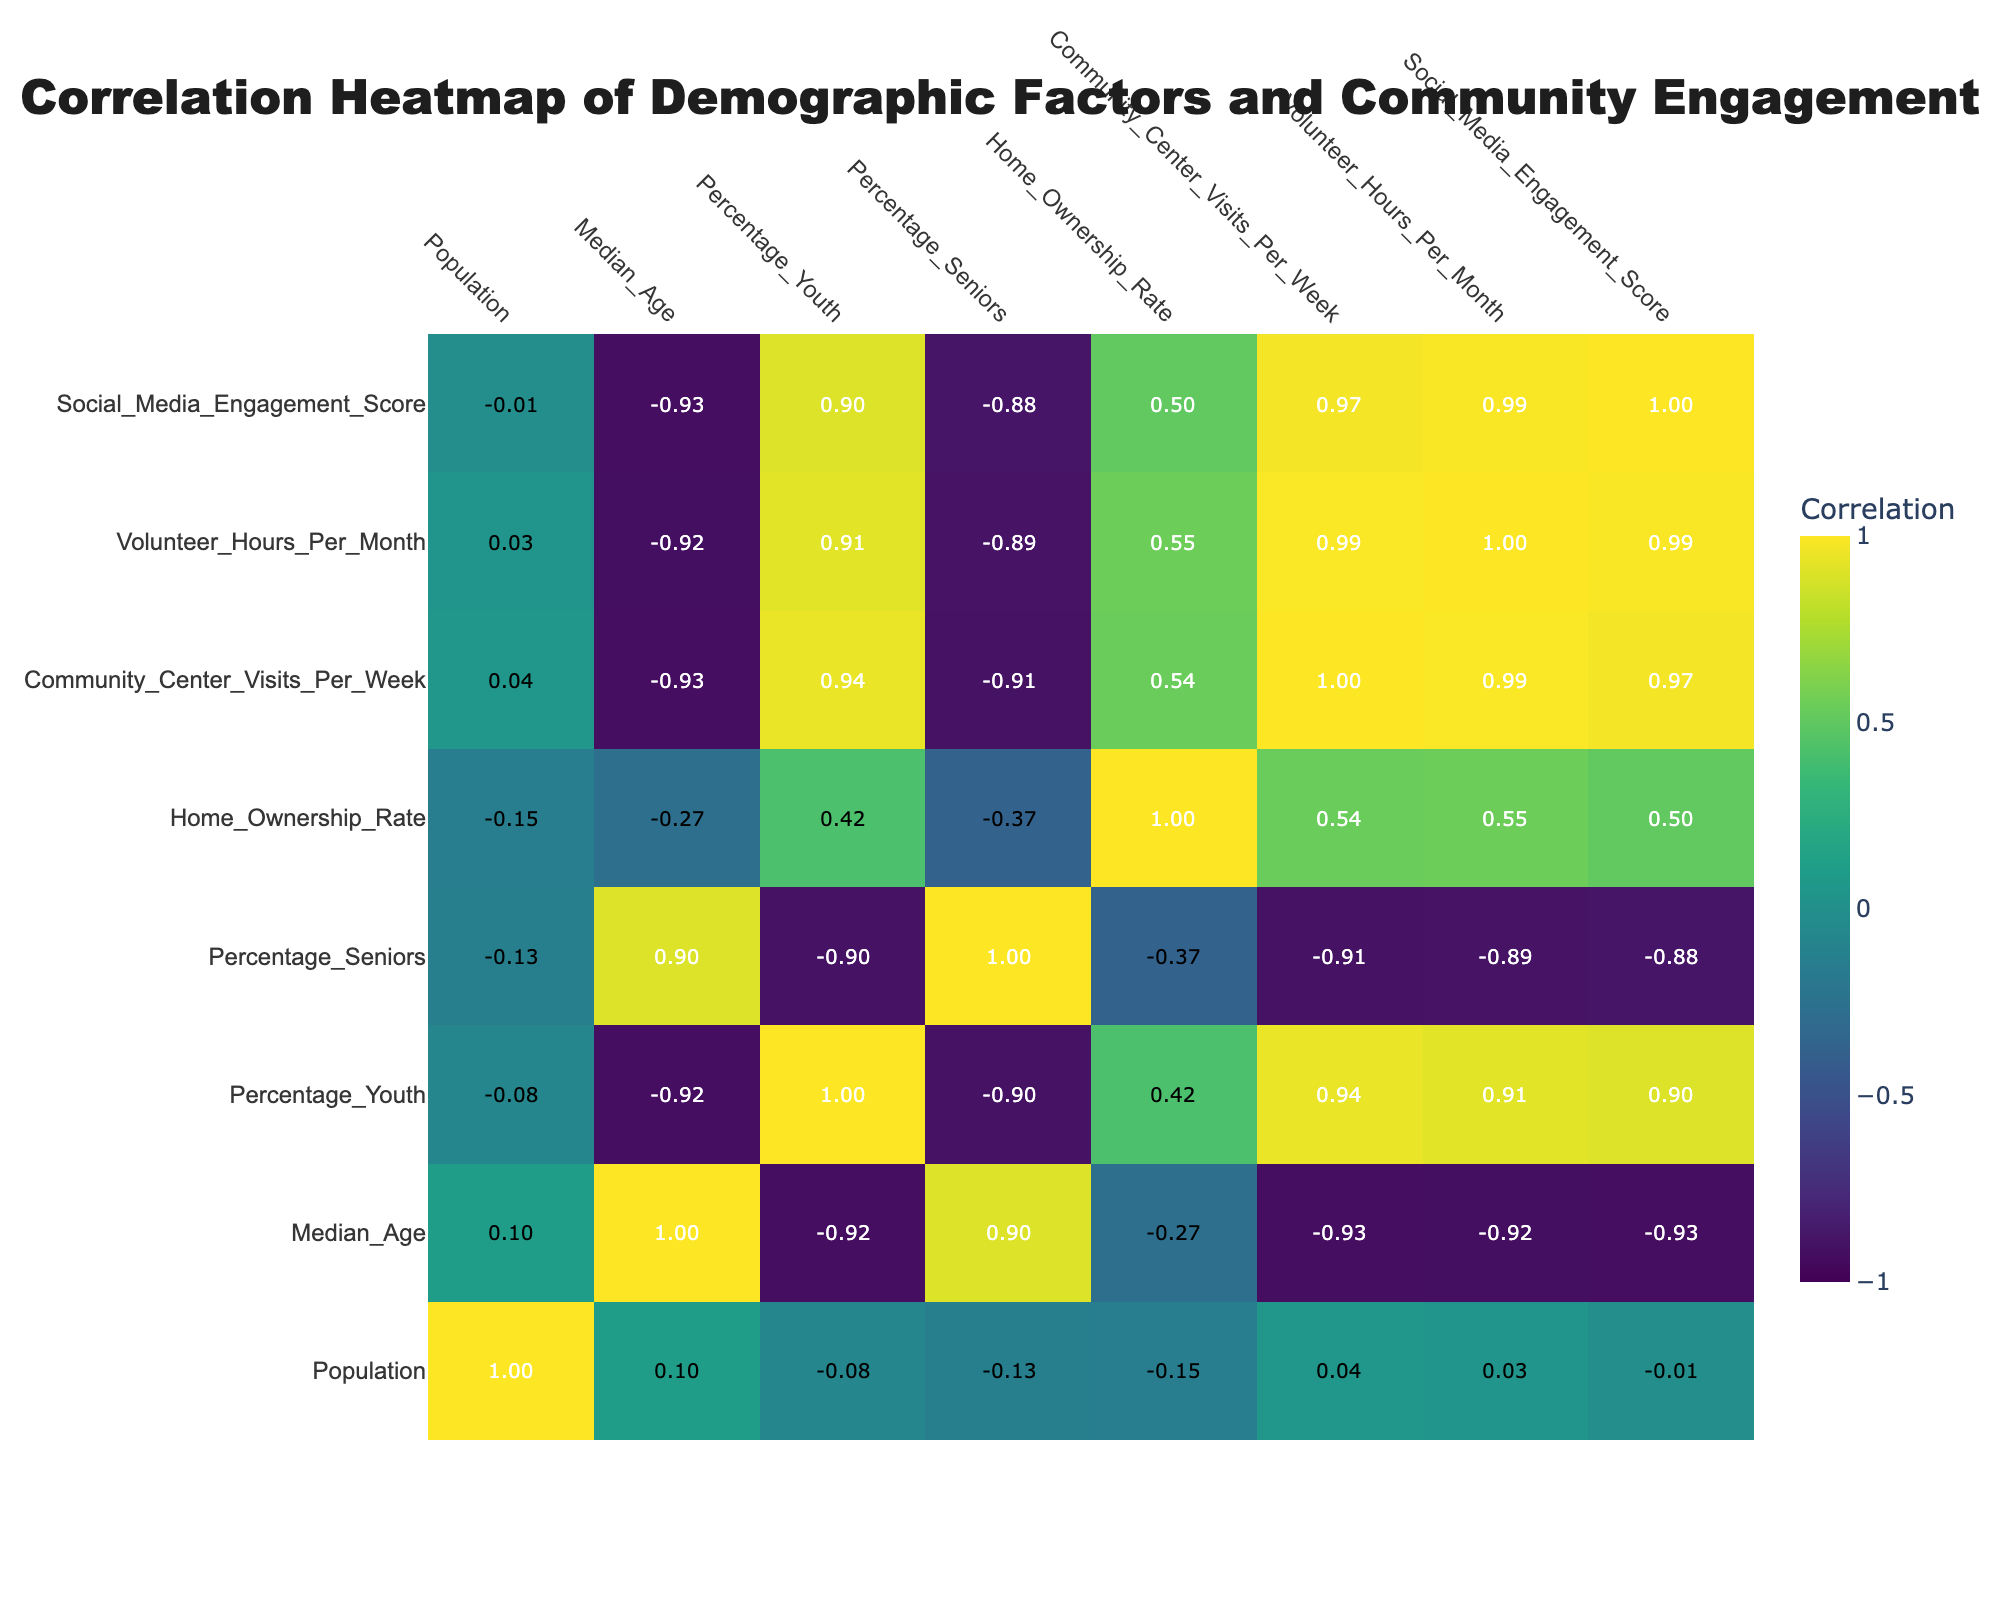What is the median age of the Downtown neighborhood? The table indicates that Downtown has a median age of 30 years.
Answer: 30 Which neighborhood has the highest percentage of seniors? By examining the data, Riverside has the highest percentage of seniors at 20%.
Answer: 20 What is the correlation between home ownership rate and volunteer hours per month? Looking at the correlation values in the table, the correlation between home ownership rate and volunteer hours per month is 0.27, indicating a low positive correlation.
Answer: 0.27 Which neighborhood has the lowest community center visits per week, and what is that number? Old Town is the neighborhood with the lowest community center visits per week recorded at 20 visits.
Answer: 20 If we consider only neighborhoods with a home ownership rate of 65% or higher, what is the average percentage of youth in those neighborhoods? The neighborhoods with home ownership rates of 65% or higher are Greenfield (45% youth) and Eastwood (50% youth). The average percentage of youth is (45 + 50)/2 = 47.5%.
Answer: 47.5 Is there a neighborhood where the social media engagement score is above 200? By checking the social media engagement scores, we see that Greenfield (220) and Eastwood (210) have scores above 200.
Answer: Yes Which neighborhood has the highest correlation between community center visits per week and social media engagement score? The data shows that the highest correlation between community center visits and social media engagement is in the Eastwood neighborhood, with a correlation of 0.75.
Answer: Eastwood What is the difference in percentage of youth between the neighborhood with the lowest and the highest percentage of youth? Riverside has the lowest percentage of youth (25%), and Downtown has the highest (40%). The difference is 40 - 25 = 15%.
Answer: 15 How many neighborhoods have a population greater than 10,000? By reviewing the neighborhoods, only three have populations greater than 10,000: Downtown (15,000), Riverside (12,000), and Lakeside (11,000). Thus, there are 3 neighborhoods.
Answer: 3 